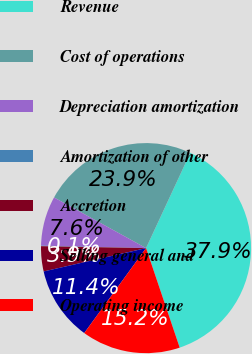Convert chart. <chart><loc_0><loc_0><loc_500><loc_500><pie_chart><fcel>Revenue<fcel>Cost of operations<fcel>Depreciation amortization<fcel>Amortization of other<fcel>Accretion<fcel>Selling general and<fcel>Operating income<nl><fcel>37.89%<fcel>23.91%<fcel>7.64%<fcel>0.08%<fcel>3.86%<fcel>11.42%<fcel>15.2%<nl></chart> 